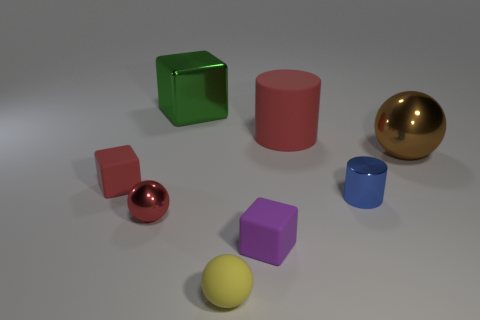Which objects in this scene are reflective, and how can you tell? The most reflective objects in the scene are the green cube and the golden sphere. You can tell by the clear, sharp reflections on their surfaces that capture the environment and light sources. The blue cylinder also exhibits some reflectiveness, though to a lesser degree. Objects that are not reflective, like the brown sphere and the purple cube, do not have these distinct reflections and instead have a more uniformly colored surface. 